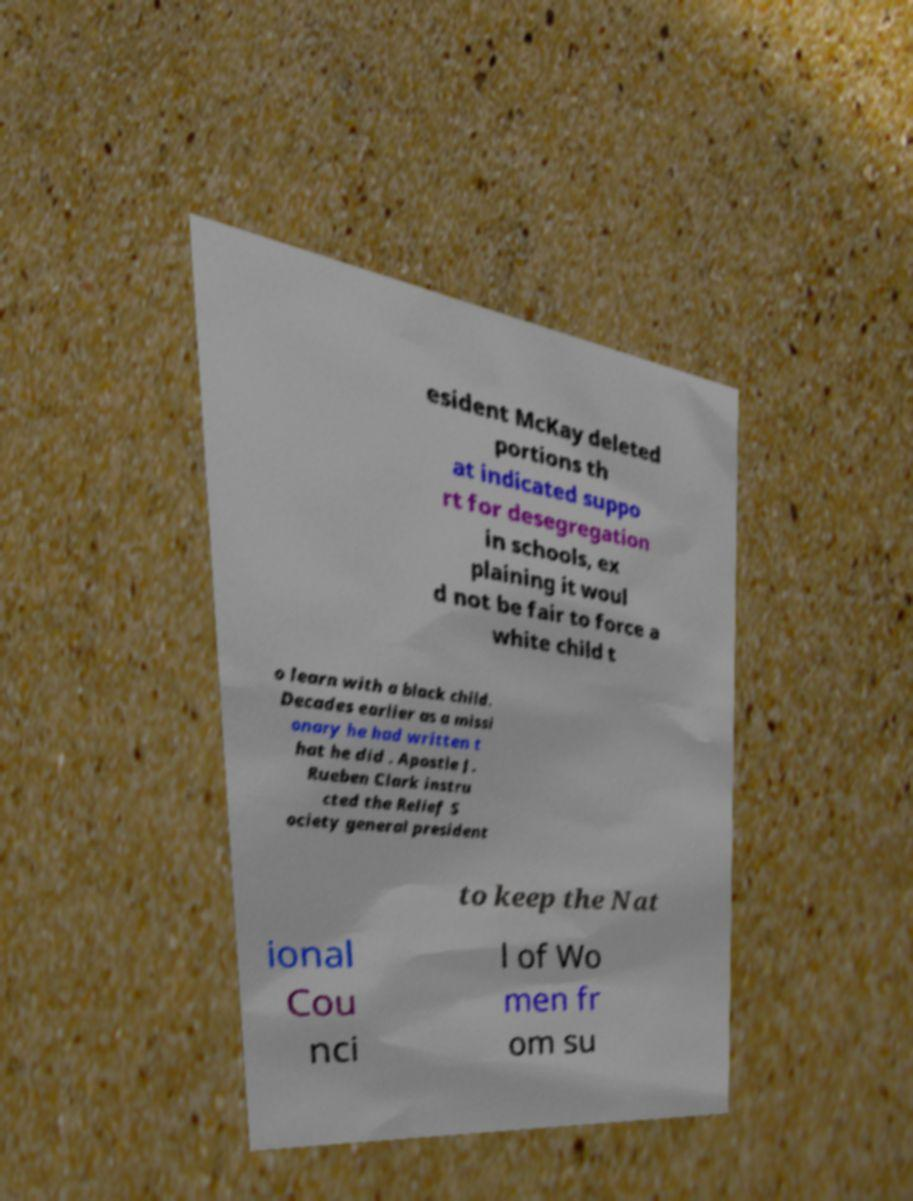For documentation purposes, I need the text within this image transcribed. Could you provide that? esident McKay deleted portions th at indicated suppo rt for desegregation in schools, ex plaining it woul d not be fair to force a white child t o learn with a black child. Decades earlier as a missi onary he had written t hat he did . Apostle J. Rueben Clark instru cted the Relief S ociety general president to keep the Nat ional Cou nci l of Wo men fr om su 